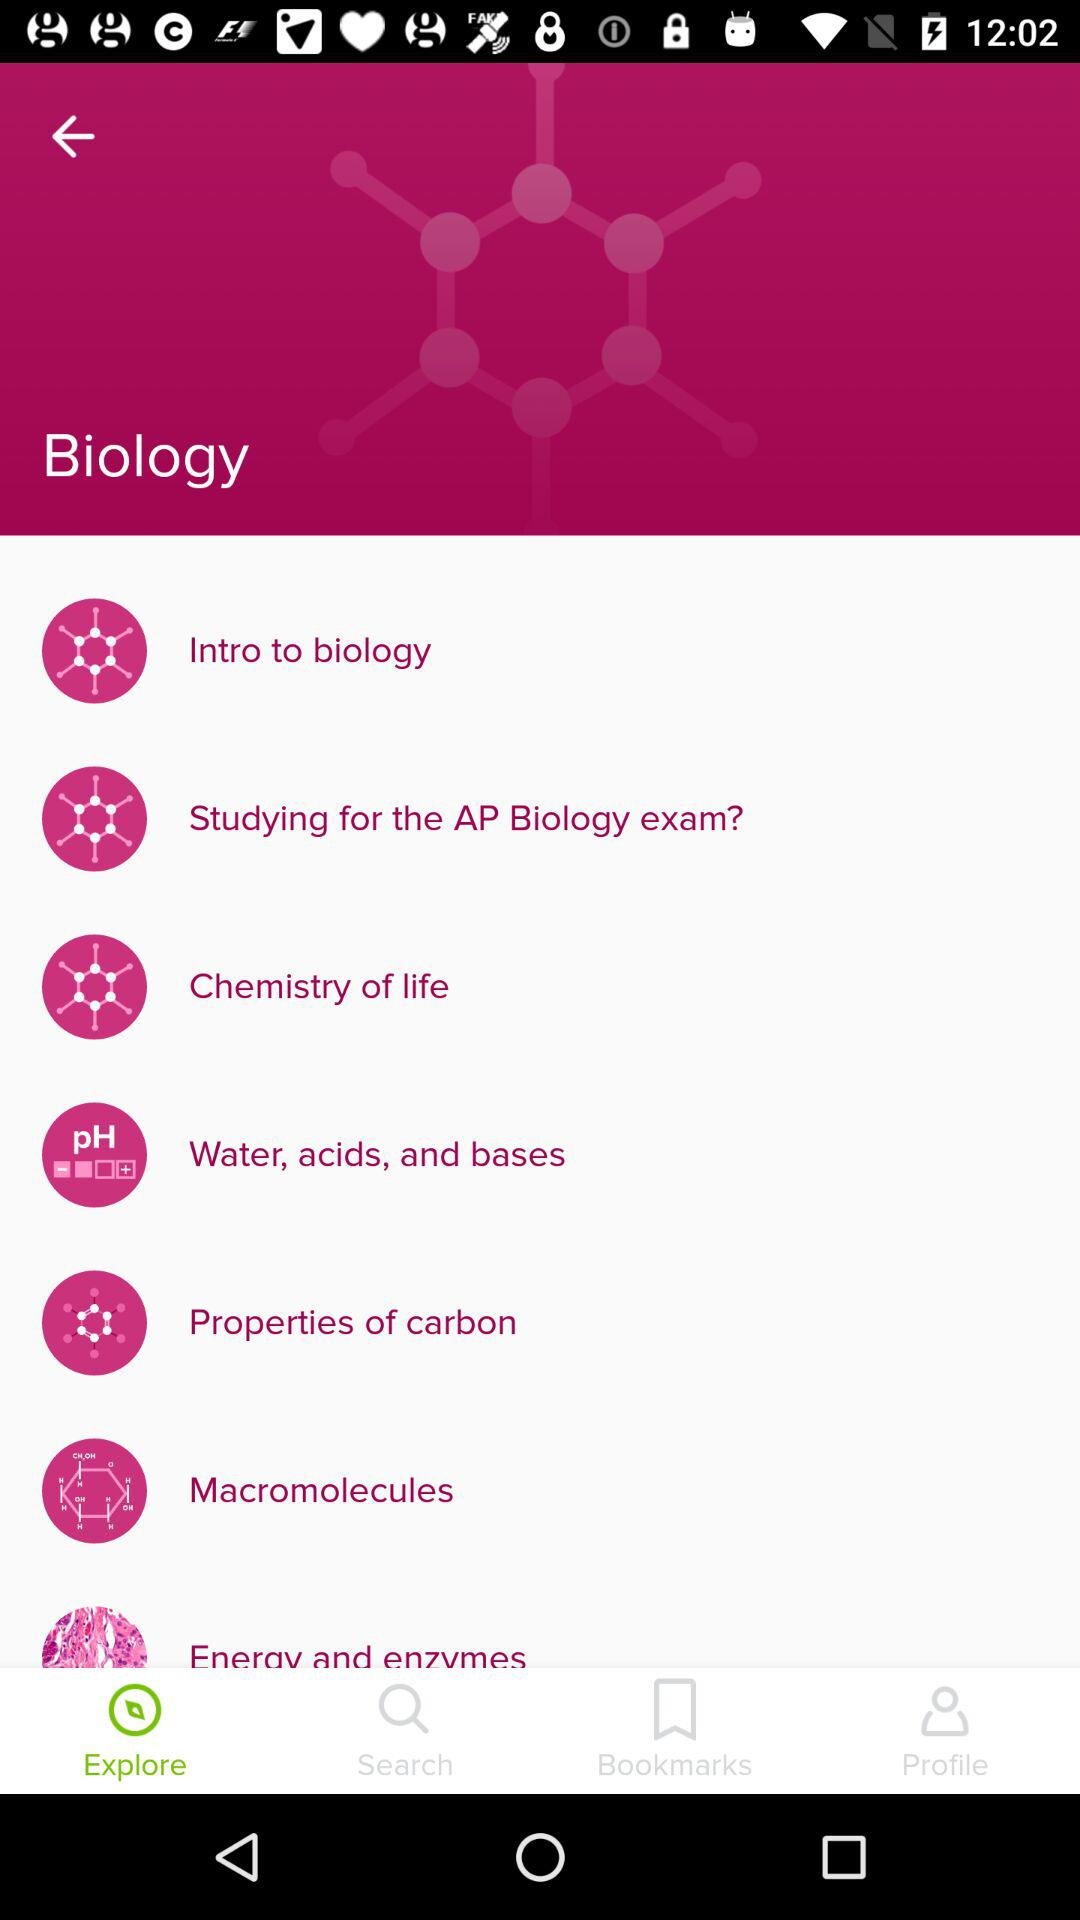What is the subject name? The subject name is biology. 